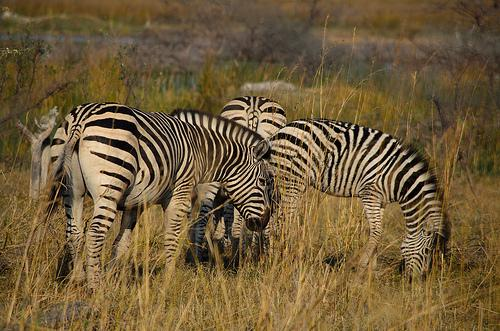Please count the number of zebras in the picture. There are three zebras in the image. What are the main colors of the zebra's fur in the image? The zebra's fur is black and white. Identify which species are present in this image and what are their activities. Zebras are present in the image, and they are standing together, eating grass. What emotions do you feel when looking at the image? The image makes me feel serene and tranquil due to the peaceful nature scene with zebras. Describe the physical state of trees and the river in the background. There are both dead and fallen tree trunks in the picture, and a river is visible in the distance. Explain a complex reasoning task in this image. To understand the zebras' behavior, consider their living environment, the available food resources, and how they interact with the landscape. What kind of grass is present in the picture and describe the overall sentiment of the image? Tall, yellow, and parched grass is present in the image, which evokes a calm and peaceful sentiment. What are some features of the zebras in the image? The zebras have long legs, black and white stripes, and a fluffy tail. Provide a brief description of the image. Multiple zebras are grazing in a field with tall grass, a dead tree and a river in the distance. Describe the interaction between the objects in the image. Zebras are grazing on the grass, interacting with the field, while fallen and dead trees lay among the grass, and there's a river in the distance. 